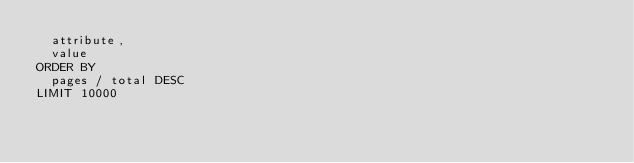<code> <loc_0><loc_0><loc_500><loc_500><_SQL_>  attribute,
  value
ORDER BY
  pages / total DESC
LIMIT 10000
</code> 